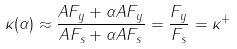Convert formula to latex. <formula><loc_0><loc_0><loc_500><loc_500>\kappa ( \alpha ) \approx \frac { A F _ { y } + \alpha A F _ { y } } { A F _ { s } + \alpha A F _ { s } } = \frac { F _ { y } } { F _ { s } } = \kappa ^ { + }</formula> 